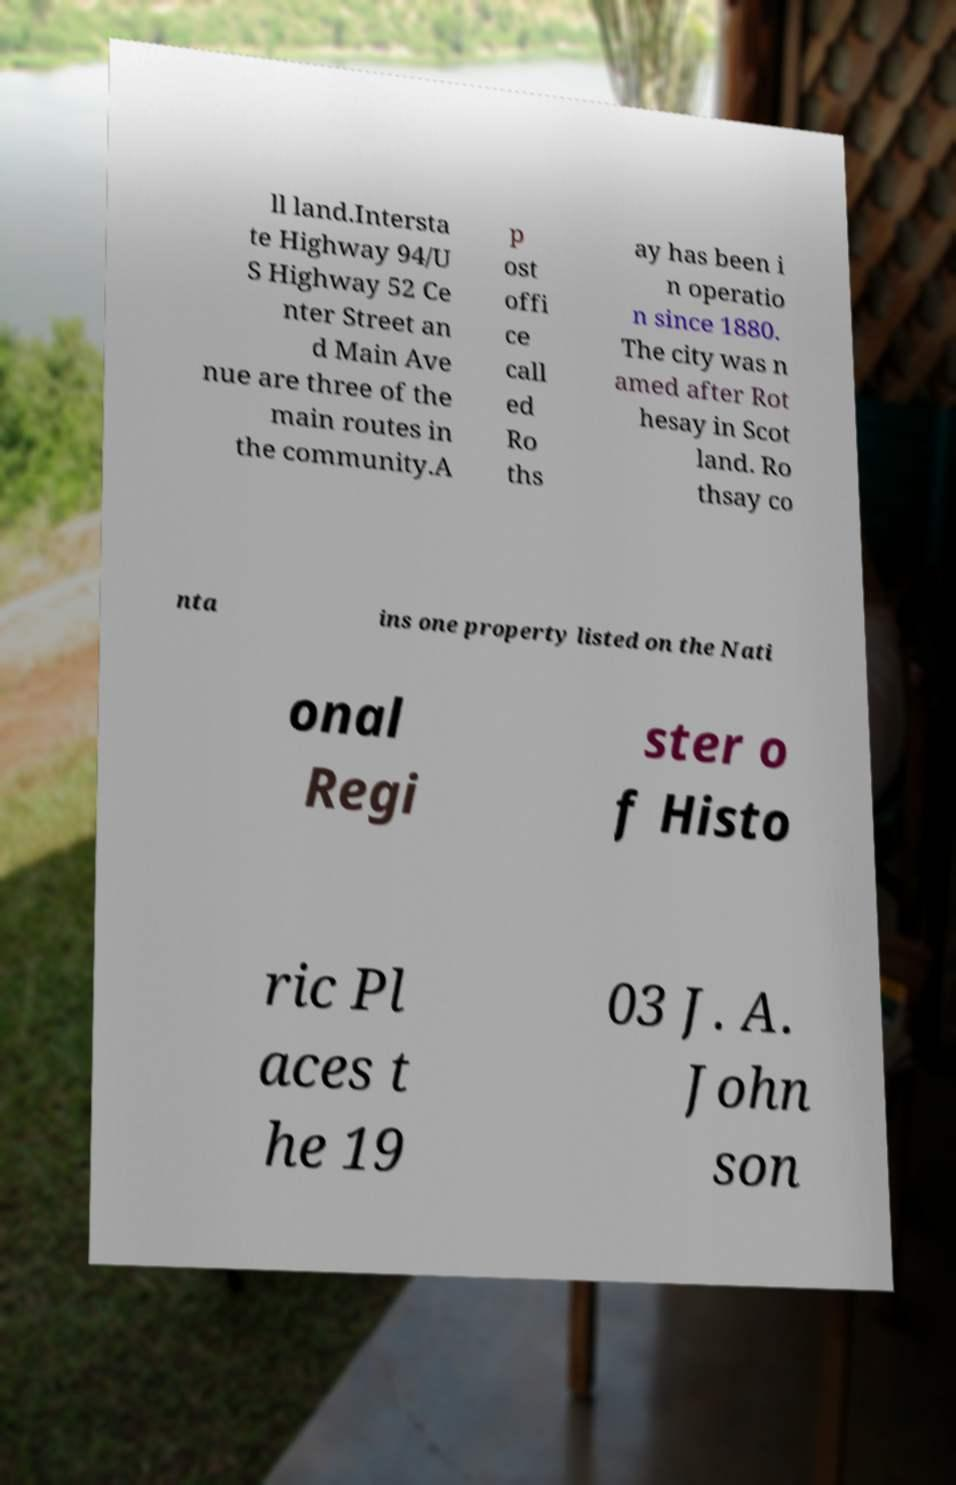Please read and relay the text visible in this image. What does it say? ll land.Intersta te Highway 94/U S Highway 52 Ce nter Street an d Main Ave nue are three of the main routes in the community.A p ost offi ce call ed Ro ths ay has been i n operatio n since 1880. The city was n amed after Rot hesay in Scot land. Ro thsay co nta ins one property listed on the Nati onal Regi ster o f Histo ric Pl aces t he 19 03 J. A. John son 